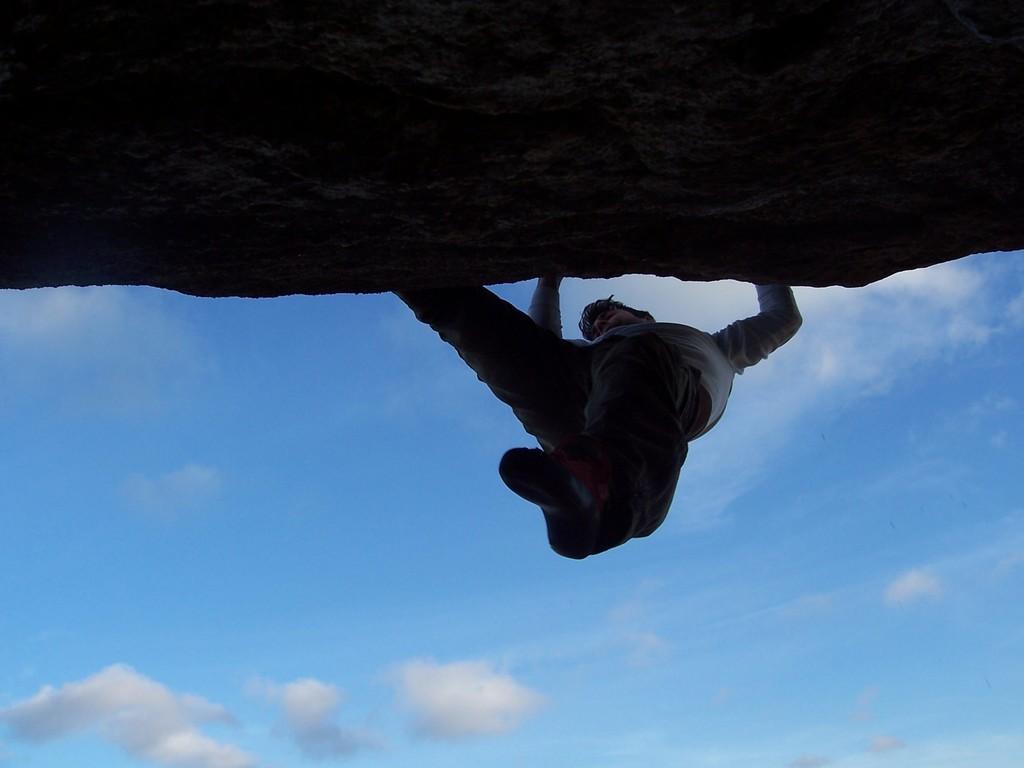How would you summarize this image in a sentence or two? In the center of the image a person is climbing the hill. At the bottom of the image clouds are present in the sky. 